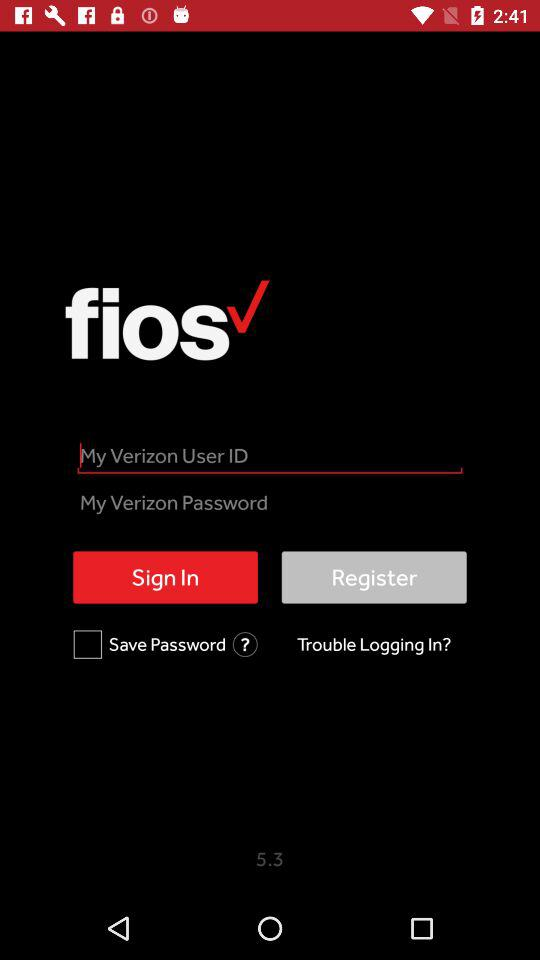What is the status of the "Save password" checkbox? The status is "off". 